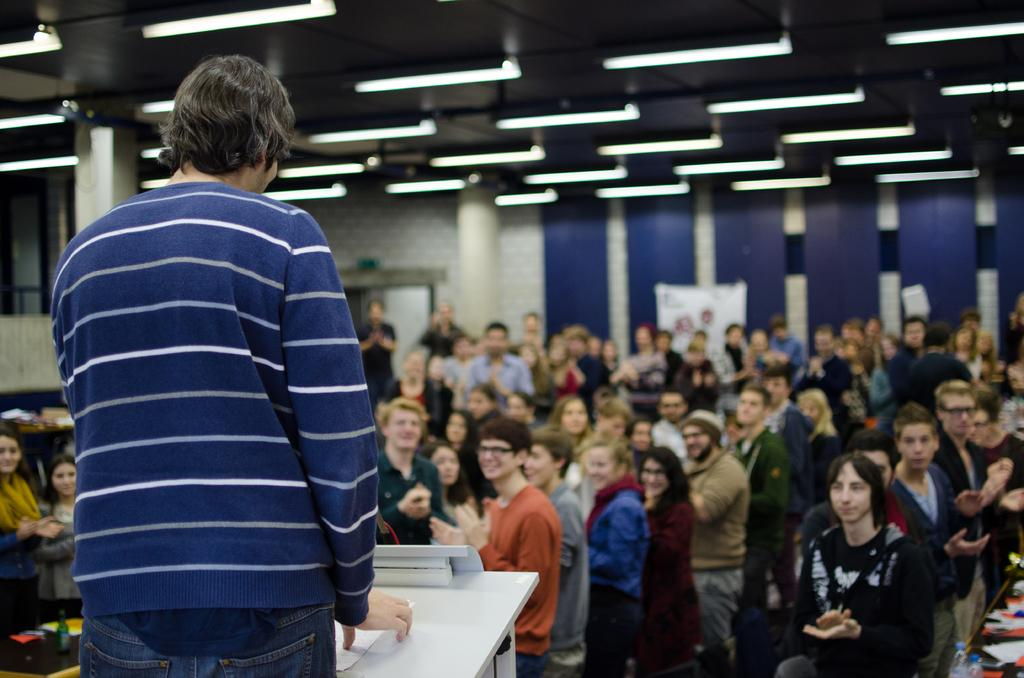What is the person in front of the table doing? The person is standing in front of a table and holding a paper. What might the person be doing with the paper? The person might be presenting or reading the paper. What are the other people in the image doing? The other people are clapping their hands. What can be seen on the roof in the image? There are lights on the roof. What type of pain is the person experiencing while holding the paper? There is no indication in the image that the person is experiencing any pain, and the image does not provide any information about the person's emotional or physical state. 